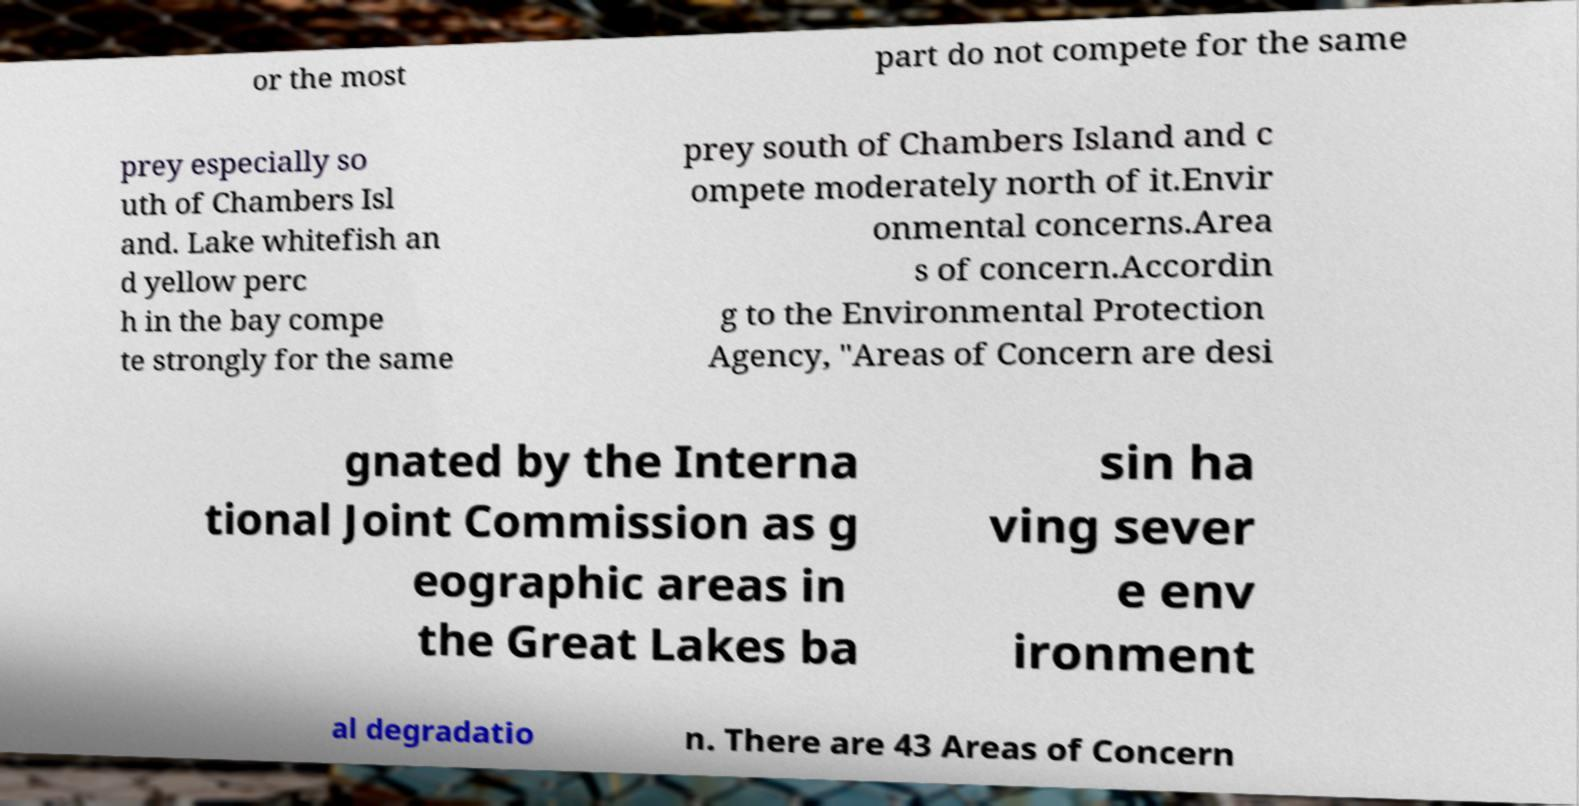Can you accurately transcribe the text from the provided image for me? or the most part do not compete for the same prey especially so uth of Chambers Isl and. Lake whitefish an d yellow perc h in the bay compe te strongly for the same prey south of Chambers Island and c ompete moderately north of it.Envir onmental concerns.Area s of concern.Accordin g to the Environmental Protection Agency, "Areas of Concern are desi gnated by the Interna tional Joint Commission as g eographic areas in the Great Lakes ba sin ha ving sever e env ironment al degradatio n. There are 43 Areas of Concern 